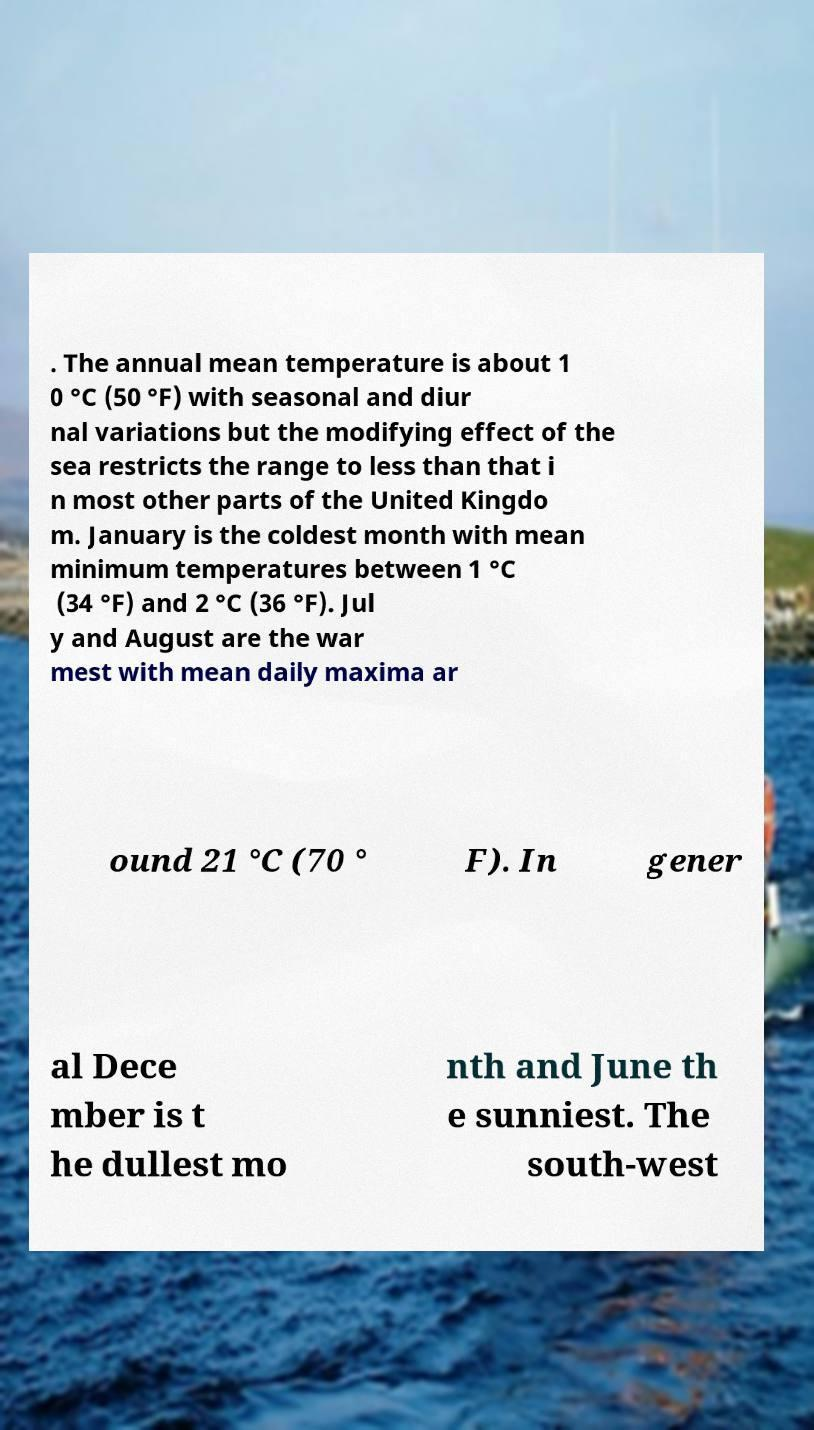What messages or text are displayed in this image? I need them in a readable, typed format. . The annual mean temperature is about 1 0 °C (50 °F) with seasonal and diur nal variations but the modifying effect of the sea restricts the range to less than that i n most other parts of the United Kingdo m. January is the coldest month with mean minimum temperatures between 1 °C (34 °F) and 2 °C (36 °F). Jul y and August are the war mest with mean daily maxima ar ound 21 °C (70 ° F). In gener al Dece mber is t he dullest mo nth and June th e sunniest. The south-west 